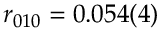Convert formula to latex. <formula><loc_0><loc_0><loc_500><loc_500>r _ { 0 1 0 } = 0 . 0 5 4 ( 4 ) \</formula> 